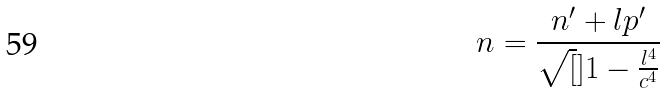Convert formula to latex. <formula><loc_0><loc_0><loc_500><loc_500>n = \frac { n ^ { \prime } + l p ^ { \prime } } { \sqrt { [ } ] { 1 - \frac { l ^ { 4 } } { c ^ { 4 } } } }</formula> 